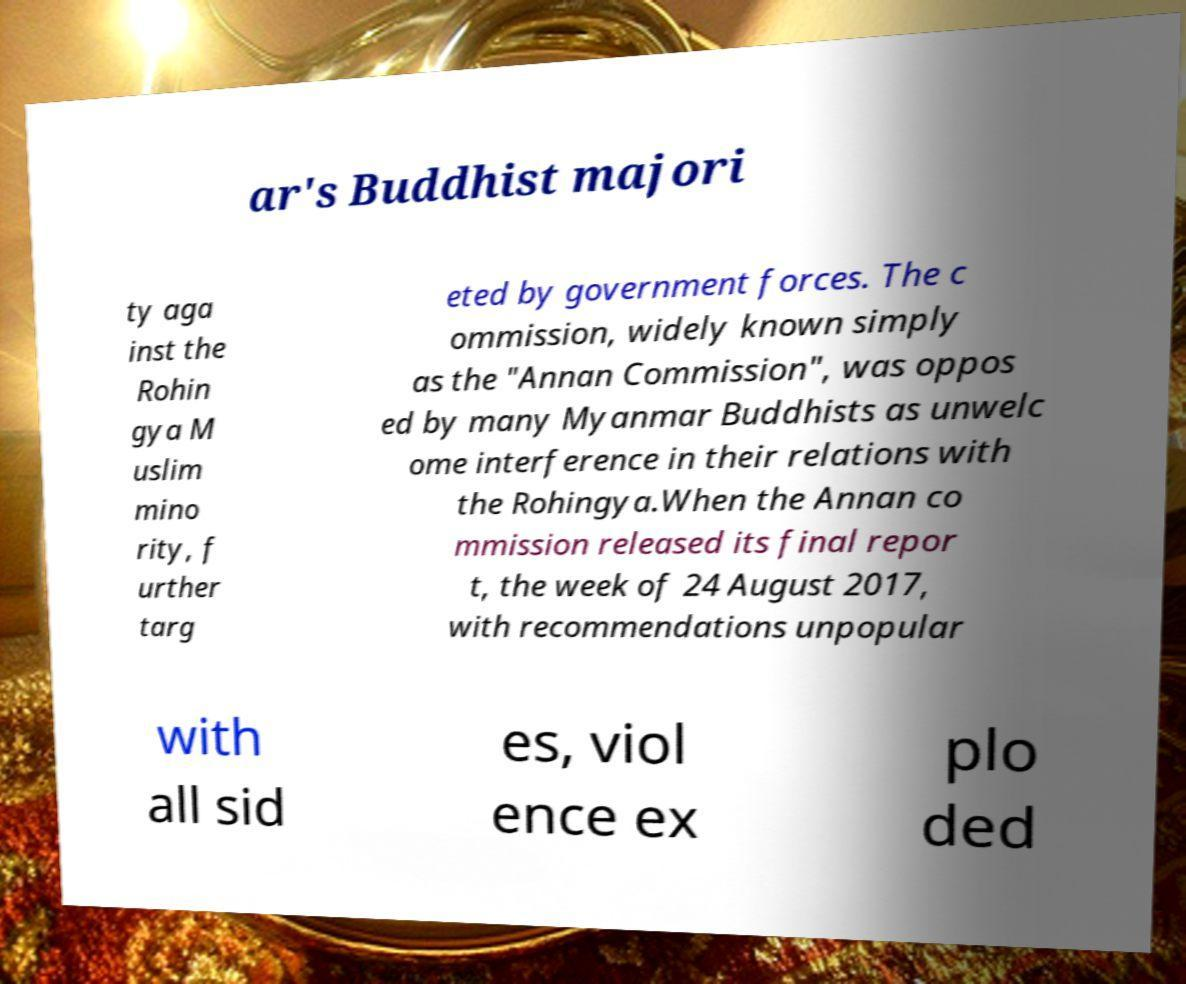For documentation purposes, I need the text within this image transcribed. Could you provide that? ar's Buddhist majori ty aga inst the Rohin gya M uslim mino rity, f urther targ eted by government forces. The c ommission, widely known simply as the "Annan Commission", was oppos ed by many Myanmar Buddhists as unwelc ome interference in their relations with the Rohingya.When the Annan co mmission released its final repor t, the week of 24 August 2017, with recommendations unpopular with all sid es, viol ence ex plo ded 